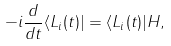<formula> <loc_0><loc_0><loc_500><loc_500>- i \frac { d } { d t } \langle L _ { i } ( t ) | = \langle L _ { i } ( t ) | H ,</formula> 